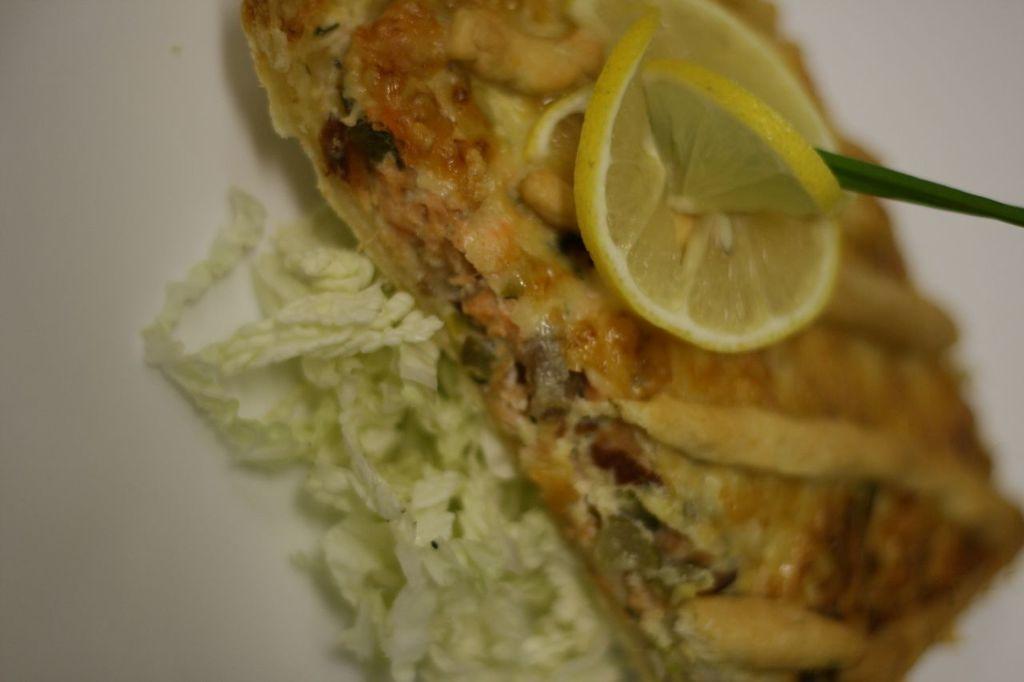Describe this image in one or two sentences. In this image we can see a food item which is decorated with lemon slices. 